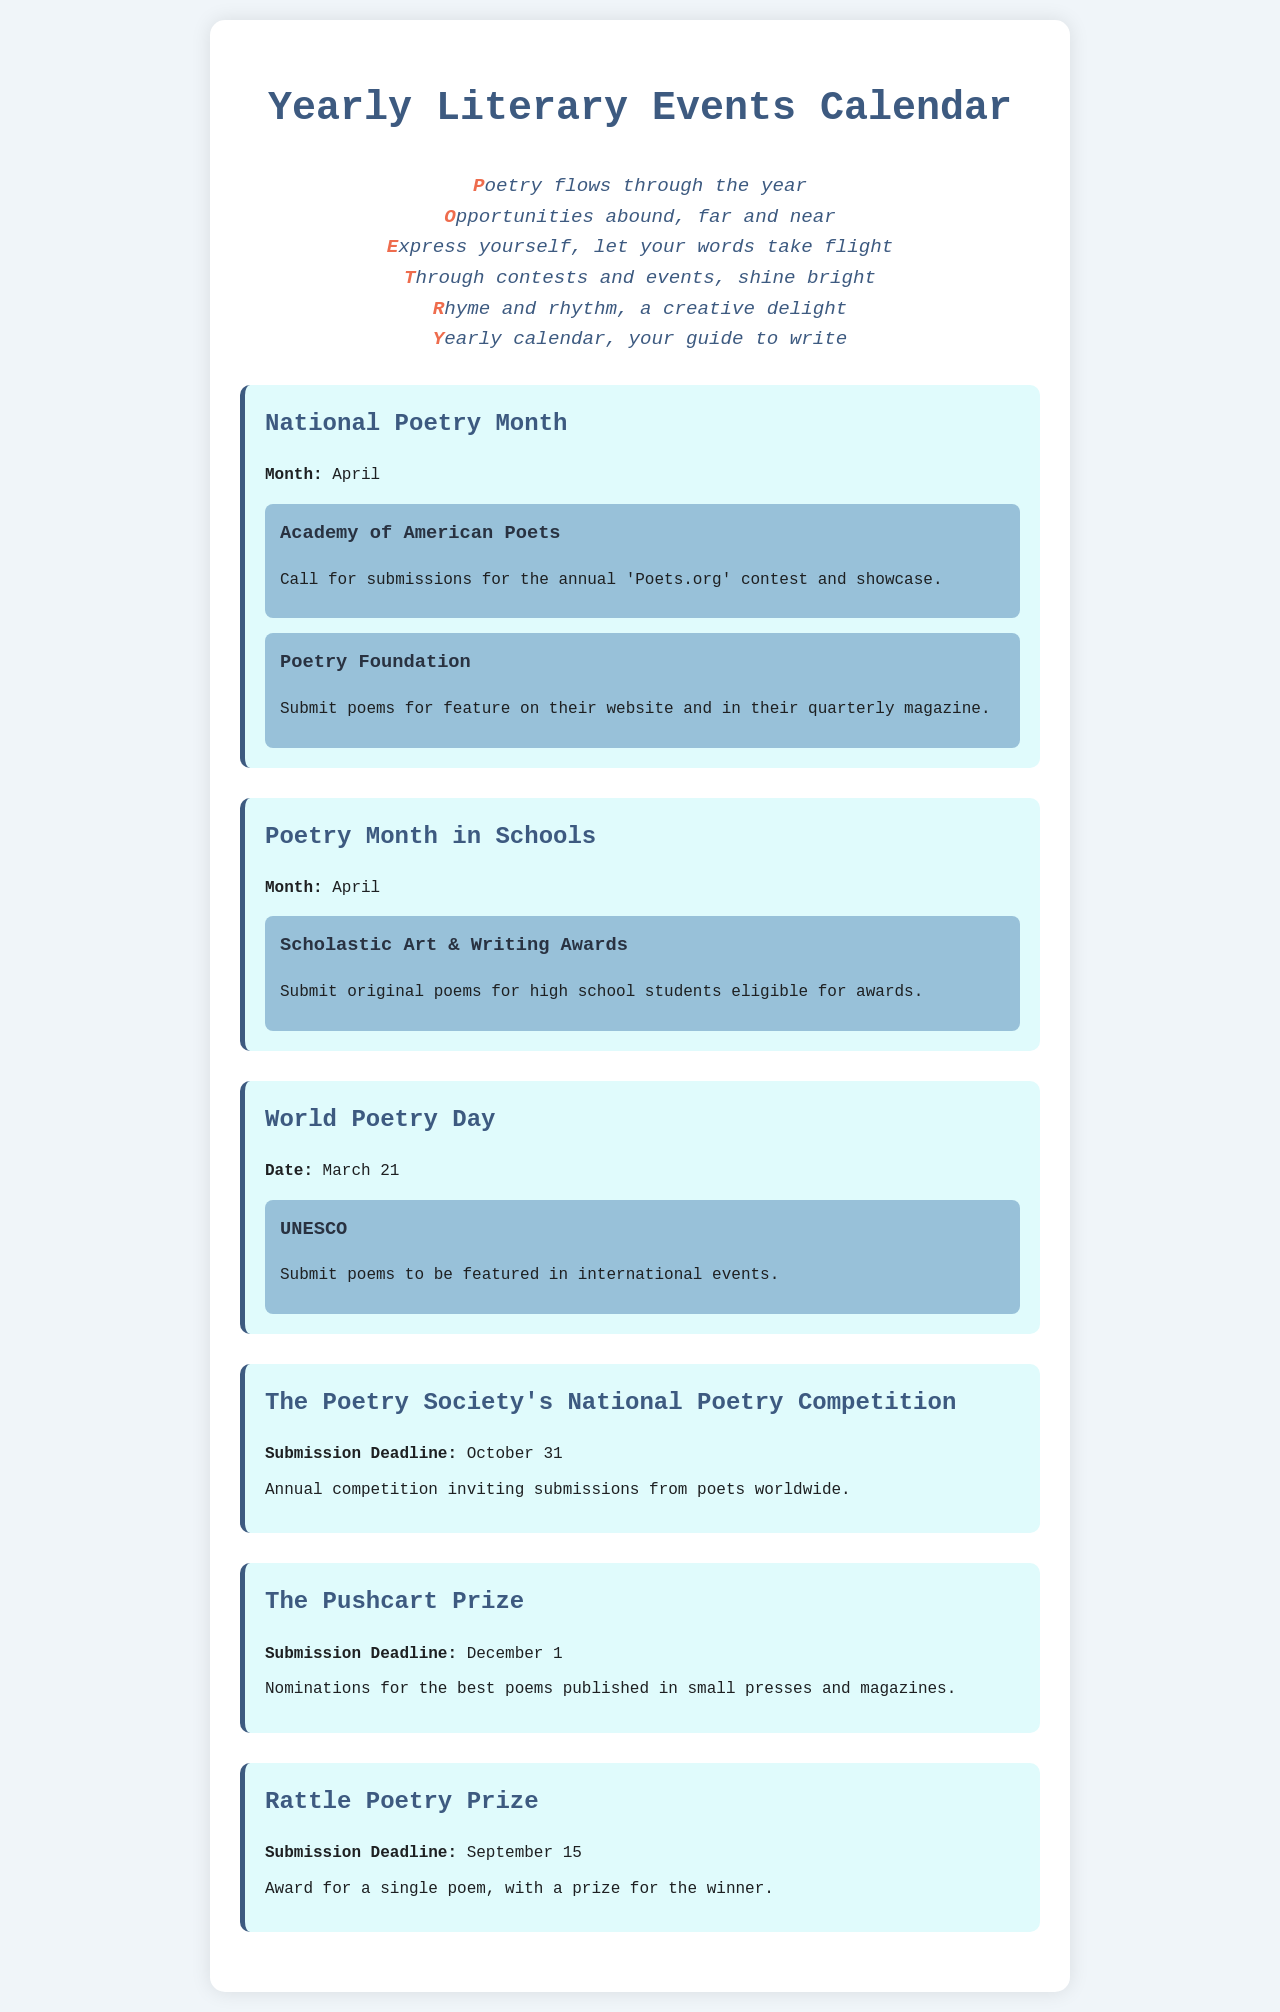What is the title of the document? The title is provided in the header of the document, which is "Yearly Literary Events Calendar."
Answer: Yearly Literary Events Calendar When is National Poetry Month? National Poetry Month is indicated in the document specifically as occurring in the month of April.
Answer: April What is the submission deadline for The Pushcart Prize? The submission deadline is mentioned in the events section of the document as December 1.
Answer: December 1 What organization is associated with World Poetry Day submissions? The organization mentioned in relation to World Poetry Day submissions is UNESCO.
Answer: UNESCO How many opportunities are listed under National Poetry Month? The document lists two opportunities for poetry submissions under National Poetry Month in the provided section.
Answer: Two What is the prize associated with the Rattle Poetry Prize? The document specifies that the Rattle Poetry Prize awards a single poem, with a prize for the winner.
Answer: A prize for the winner What month is the submission deadline for The Poetry Society's National Poetry Competition? The submission deadline for this competition is listed as October 31.
Answer: October 31 Which award allows submissions from high school students? The award that allows submissions from high school students is the Scholastic Art & Writing Awards.
Answer: Scholastic Art & Writing Awards What is the date of World Poetry Day? The document specifies that World Poetry Day occurs on March 21.
Answer: March 21 